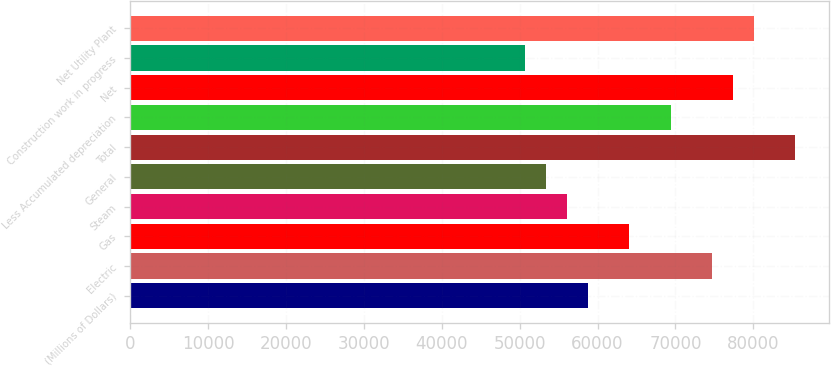Convert chart. <chart><loc_0><loc_0><loc_500><loc_500><bar_chart><fcel>(Millions of Dollars)<fcel>Electric<fcel>Gas<fcel>Steam<fcel>General<fcel>Total<fcel>Less Accumulated depreciation<fcel>Net<fcel>Construction work in progress<fcel>Net Utility Plant<nl><fcel>58716.2<fcel>74724.8<fcel>64052.4<fcel>56048.1<fcel>53380<fcel>85397.2<fcel>69388.6<fcel>77392.9<fcel>50711.9<fcel>80061<nl></chart> 